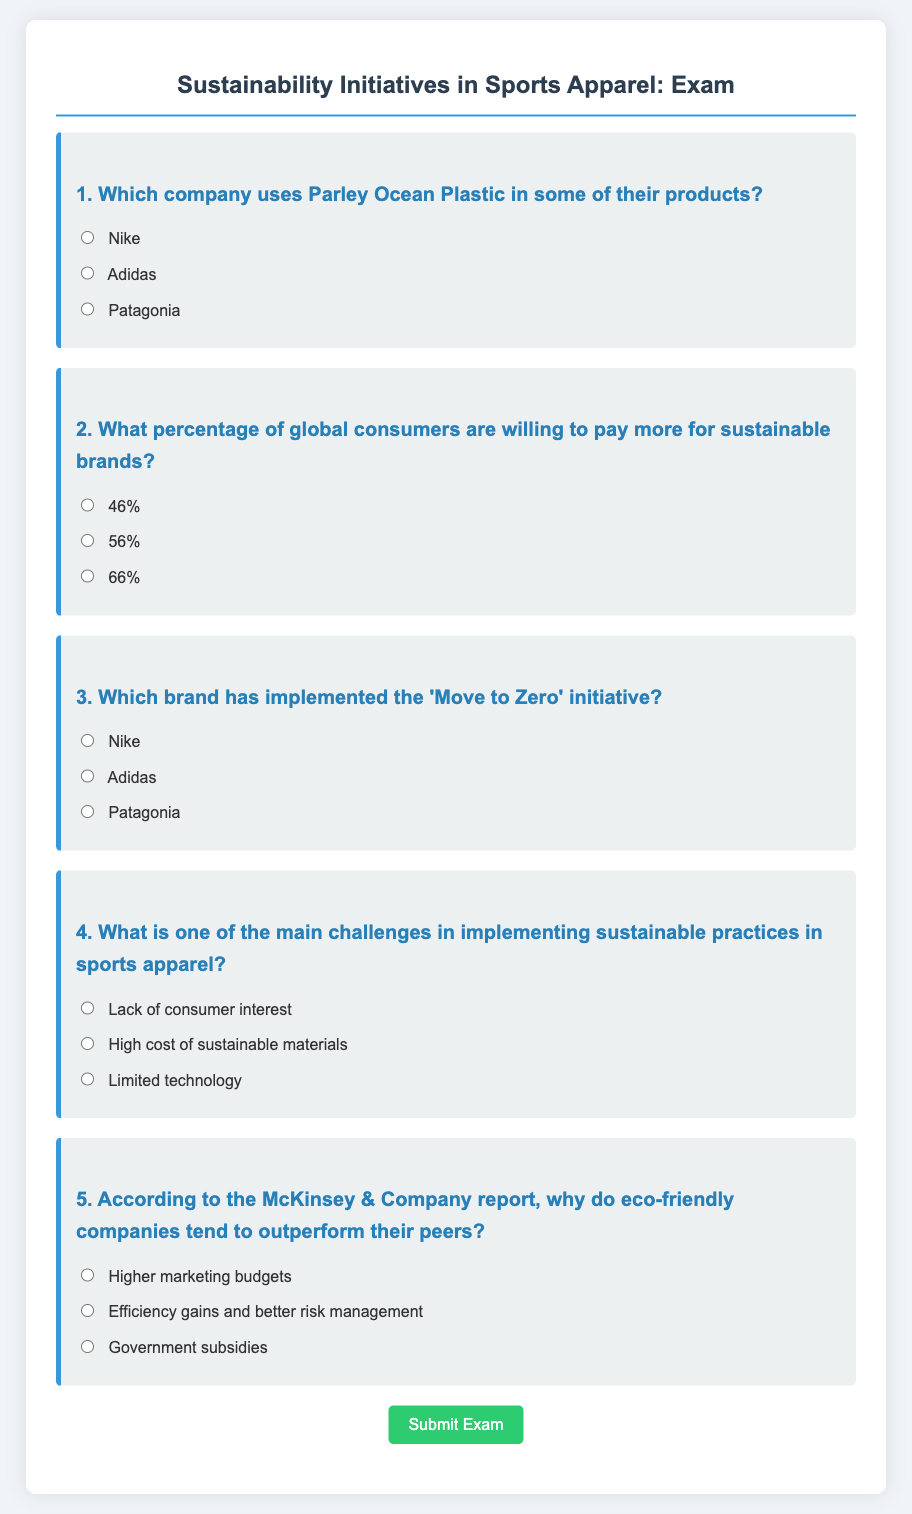Which company uses Parley Ocean Plastic in some of their products? The document lists Adidas as the company using Parley Ocean Plastic in their products.
Answer: Adidas What percentage of global consumers are willing to pay more for sustainable brands? The document states that 56% of global consumers are willing to pay more for sustainable brands.
Answer: 56% Which brand has implemented the 'Move to Zero' initiative? According to the document, Nike is the brand that has implemented the 'Move to Zero' initiative.
Answer: Nike What is one of the main challenges in implementing sustainable practices in sports apparel? The document highlights the high cost of sustainable materials as one of the main challenges.
Answer: High cost of sustainable materials According to the McKinsey & Company report, why do eco-friendly companies tend to outperform their peers? The document indicates that eco-friendly companies outperform due to efficiency gains and better risk management.
Answer: Efficiency gains and better risk management 